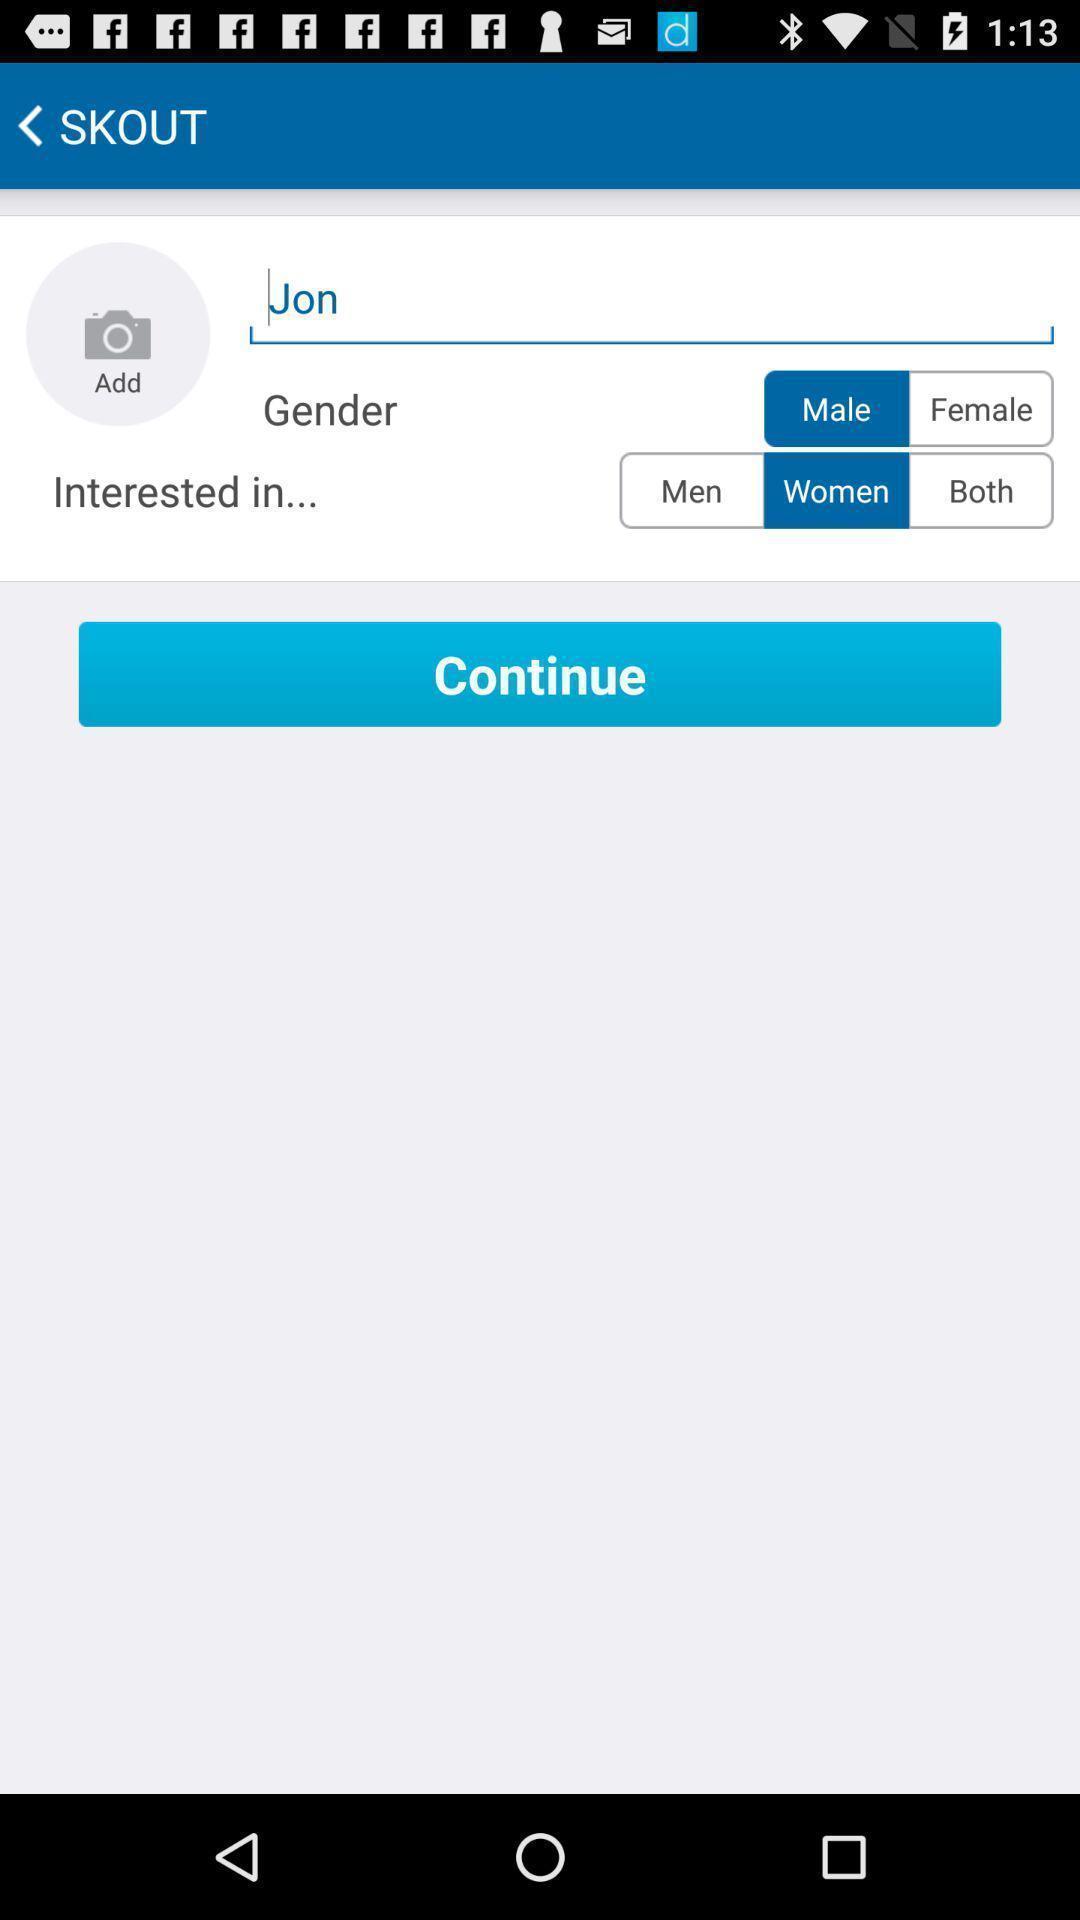Tell me what you see in this picture. Screen displaying page. 